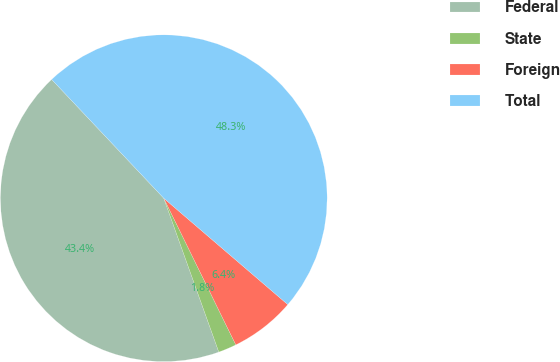Convert chart. <chart><loc_0><loc_0><loc_500><loc_500><pie_chart><fcel>Federal<fcel>State<fcel>Foreign<fcel>Total<nl><fcel>43.43%<fcel>1.8%<fcel>6.45%<fcel>48.32%<nl></chart> 